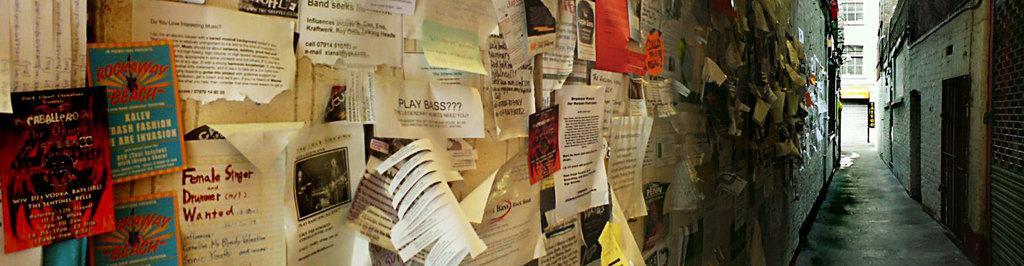How would you summarize this image in a sentence or two? As we can see in the image there are buildings and papers attached to walls. 